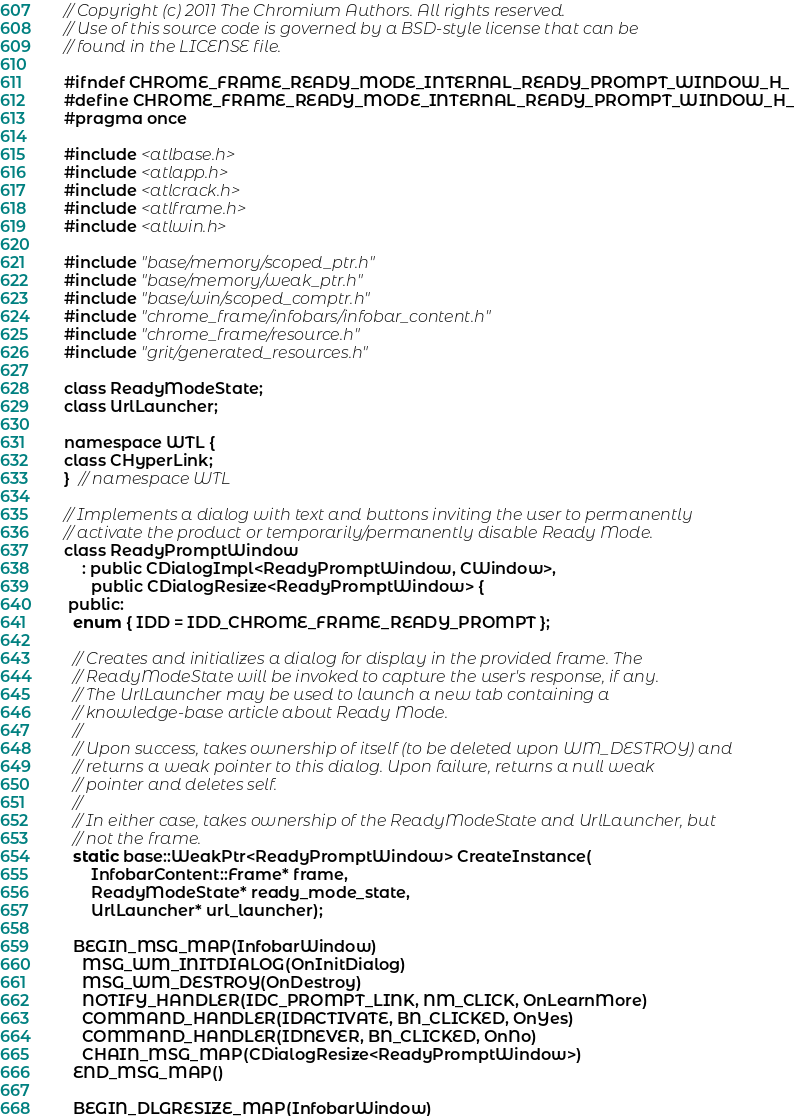Convert code to text. <code><loc_0><loc_0><loc_500><loc_500><_C_>// Copyright (c) 2011 The Chromium Authors. All rights reserved.
// Use of this source code is governed by a BSD-style license that can be
// found in the LICENSE file.

#ifndef CHROME_FRAME_READY_MODE_INTERNAL_READY_PROMPT_WINDOW_H_
#define CHROME_FRAME_READY_MODE_INTERNAL_READY_PROMPT_WINDOW_H_
#pragma once

#include <atlbase.h>
#include <atlapp.h>
#include <atlcrack.h>
#include <atlframe.h>
#include <atlwin.h>

#include "base/memory/scoped_ptr.h"
#include "base/memory/weak_ptr.h"
#include "base/win/scoped_comptr.h"
#include "chrome_frame/infobars/infobar_content.h"
#include "chrome_frame/resource.h"
#include "grit/generated_resources.h"

class ReadyModeState;
class UrlLauncher;

namespace WTL {
class CHyperLink;
}  // namespace WTL

// Implements a dialog with text and buttons inviting the user to permanently
// activate the product or temporarily/permanently disable Ready Mode.
class ReadyPromptWindow
    : public CDialogImpl<ReadyPromptWindow, CWindow>,
      public CDialogResize<ReadyPromptWindow> {
 public:
  enum { IDD = IDD_CHROME_FRAME_READY_PROMPT };

  // Creates and initializes a dialog for display in the provided frame. The
  // ReadyModeState will be invoked to capture the user's response, if any.
  // The UrlLauncher may be used to launch a new tab containing a
  // knowledge-base article about Ready Mode.
  //
  // Upon success, takes ownership of itself (to be deleted upon WM_DESTROY) and
  // returns a weak pointer to this dialog. Upon failure, returns a null weak
  // pointer and deletes self.
  //
  // In either case, takes ownership of the ReadyModeState and UrlLauncher, but
  // not the frame.
  static base::WeakPtr<ReadyPromptWindow> CreateInstance(
      InfobarContent::Frame* frame,
      ReadyModeState* ready_mode_state,
      UrlLauncher* url_launcher);

  BEGIN_MSG_MAP(InfobarWindow)
    MSG_WM_INITDIALOG(OnInitDialog)
    MSG_WM_DESTROY(OnDestroy)
    NOTIFY_HANDLER(IDC_PROMPT_LINK, NM_CLICK, OnLearnMore)
    COMMAND_HANDLER(IDACTIVATE, BN_CLICKED, OnYes)
    COMMAND_HANDLER(IDNEVER, BN_CLICKED, OnNo)
    CHAIN_MSG_MAP(CDialogResize<ReadyPromptWindow>)
  END_MSG_MAP()

  BEGIN_DLGRESIZE_MAP(InfobarWindow)</code> 